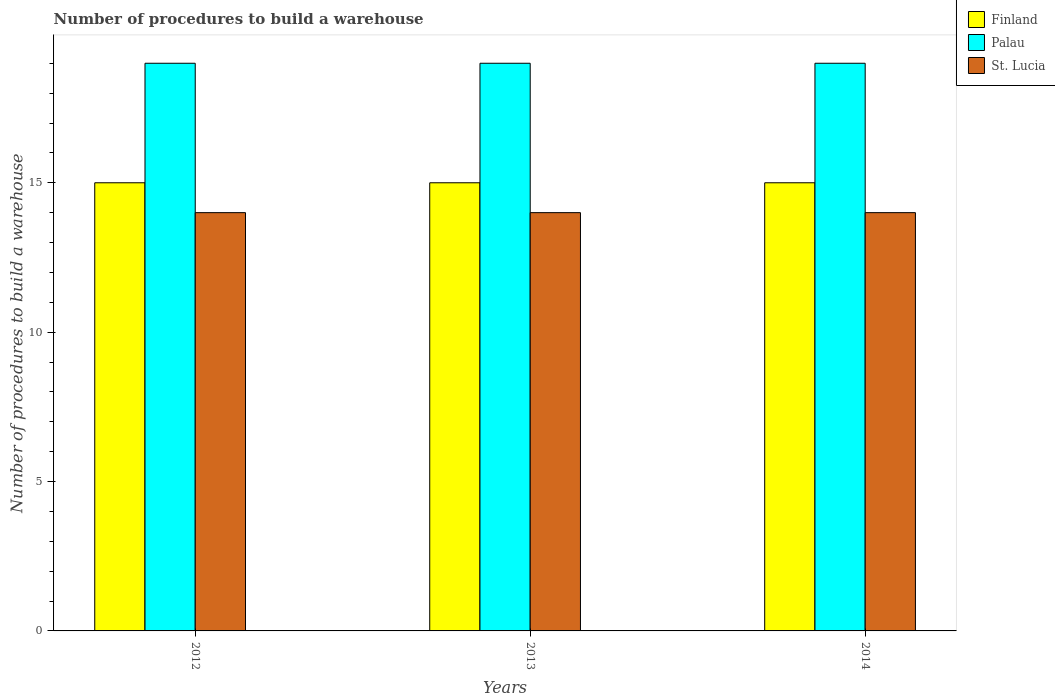How many bars are there on the 1st tick from the left?
Provide a short and direct response. 3. How many bars are there on the 2nd tick from the right?
Your answer should be very brief. 3. What is the label of the 1st group of bars from the left?
Give a very brief answer. 2012. In how many cases, is the number of bars for a given year not equal to the number of legend labels?
Keep it short and to the point. 0. What is the number of procedures to build a warehouse in in St. Lucia in 2013?
Offer a very short reply. 14. Across all years, what is the maximum number of procedures to build a warehouse in in St. Lucia?
Offer a terse response. 14. Across all years, what is the minimum number of procedures to build a warehouse in in Finland?
Ensure brevity in your answer.  15. In which year was the number of procedures to build a warehouse in in Finland maximum?
Your answer should be compact. 2012. In which year was the number of procedures to build a warehouse in in Palau minimum?
Provide a short and direct response. 2012. What is the total number of procedures to build a warehouse in in St. Lucia in the graph?
Provide a short and direct response. 42. What is the difference between the number of procedures to build a warehouse in in Finland in 2012 and that in 2013?
Provide a succinct answer. 0. What is the difference between the number of procedures to build a warehouse in in Finland in 2014 and the number of procedures to build a warehouse in in St. Lucia in 2013?
Provide a succinct answer. 1. In the year 2014, what is the difference between the number of procedures to build a warehouse in in Finland and number of procedures to build a warehouse in in St. Lucia?
Give a very brief answer. 1. In how many years, is the number of procedures to build a warehouse in in Finland greater than 5?
Your answer should be very brief. 3. Is the difference between the number of procedures to build a warehouse in in Finland in 2013 and 2014 greater than the difference between the number of procedures to build a warehouse in in St. Lucia in 2013 and 2014?
Ensure brevity in your answer.  No. What does the 1st bar from the left in 2013 represents?
Make the answer very short. Finland. What does the 1st bar from the right in 2012 represents?
Offer a terse response. St. Lucia. How many bars are there?
Your answer should be compact. 9. How many years are there in the graph?
Give a very brief answer. 3. What is the difference between two consecutive major ticks on the Y-axis?
Make the answer very short. 5. Are the values on the major ticks of Y-axis written in scientific E-notation?
Your answer should be very brief. No. How are the legend labels stacked?
Keep it short and to the point. Vertical. What is the title of the graph?
Your response must be concise. Number of procedures to build a warehouse. Does "West Bank and Gaza" appear as one of the legend labels in the graph?
Make the answer very short. No. What is the label or title of the Y-axis?
Offer a very short reply. Number of procedures to build a warehouse. What is the Number of procedures to build a warehouse in St. Lucia in 2012?
Provide a succinct answer. 14. What is the Number of procedures to build a warehouse of Finland in 2013?
Ensure brevity in your answer.  15. What is the Number of procedures to build a warehouse in Palau in 2013?
Your answer should be compact. 19. What is the Number of procedures to build a warehouse in St. Lucia in 2013?
Provide a succinct answer. 14. Across all years, what is the maximum Number of procedures to build a warehouse in Finland?
Ensure brevity in your answer.  15. Across all years, what is the maximum Number of procedures to build a warehouse of Palau?
Offer a terse response. 19. Across all years, what is the minimum Number of procedures to build a warehouse in Finland?
Offer a terse response. 15. Across all years, what is the minimum Number of procedures to build a warehouse in St. Lucia?
Provide a short and direct response. 14. What is the total Number of procedures to build a warehouse in St. Lucia in the graph?
Provide a succinct answer. 42. What is the difference between the Number of procedures to build a warehouse of Finland in 2012 and that in 2013?
Keep it short and to the point. 0. What is the difference between the Number of procedures to build a warehouse in Palau in 2012 and that in 2013?
Offer a very short reply. 0. What is the difference between the Number of procedures to build a warehouse of St. Lucia in 2012 and that in 2013?
Offer a terse response. 0. What is the difference between the Number of procedures to build a warehouse in Palau in 2012 and that in 2014?
Your answer should be very brief. 0. What is the difference between the Number of procedures to build a warehouse of Palau in 2013 and that in 2014?
Give a very brief answer. 0. What is the difference between the Number of procedures to build a warehouse of Palau in 2012 and the Number of procedures to build a warehouse of St. Lucia in 2013?
Your answer should be compact. 5. What is the difference between the Number of procedures to build a warehouse in Finland in 2012 and the Number of procedures to build a warehouse in Palau in 2014?
Offer a terse response. -4. What is the difference between the Number of procedures to build a warehouse in Palau in 2012 and the Number of procedures to build a warehouse in St. Lucia in 2014?
Keep it short and to the point. 5. What is the difference between the Number of procedures to build a warehouse in Finland in 2013 and the Number of procedures to build a warehouse in Palau in 2014?
Keep it short and to the point. -4. What is the average Number of procedures to build a warehouse of Finland per year?
Your answer should be very brief. 15. What is the average Number of procedures to build a warehouse in Palau per year?
Provide a succinct answer. 19. What is the average Number of procedures to build a warehouse of St. Lucia per year?
Keep it short and to the point. 14. In the year 2012, what is the difference between the Number of procedures to build a warehouse in Palau and Number of procedures to build a warehouse in St. Lucia?
Make the answer very short. 5. In the year 2013, what is the difference between the Number of procedures to build a warehouse of Finland and Number of procedures to build a warehouse of Palau?
Give a very brief answer. -4. In the year 2013, what is the difference between the Number of procedures to build a warehouse in Finland and Number of procedures to build a warehouse in St. Lucia?
Provide a short and direct response. 1. In the year 2013, what is the difference between the Number of procedures to build a warehouse in Palau and Number of procedures to build a warehouse in St. Lucia?
Your answer should be very brief. 5. In the year 2014, what is the difference between the Number of procedures to build a warehouse in Finland and Number of procedures to build a warehouse in Palau?
Offer a very short reply. -4. What is the ratio of the Number of procedures to build a warehouse of St. Lucia in 2012 to that in 2013?
Offer a terse response. 1. What is the ratio of the Number of procedures to build a warehouse of Finland in 2012 to that in 2014?
Provide a short and direct response. 1. What is the ratio of the Number of procedures to build a warehouse of Palau in 2012 to that in 2014?
Your response must be concise. 1. What is the ratio of the Number of procedures to build a warehouse in Palau in 2013 to that in 2014?
Your answer should be compact. 1. What is the ratio of the Number of procedures to build a warehouse in St. Lucia in 2013 to that in 2014?
Offer a terse response. 1. What is the difference between the highest and the second highest Number of procedures to build a warehouse of Finland?
Your answer should be very brief. 0. What is the difference between the highest and the second highest Number of procedures to build a warehouse in St. Lucia?
Ensure brevity in your answer.  0. What is the difference between the highest and the lowest Number of procedures to build a warehouse in Finland?
Offer a very short reply. 0. What is the difference between the highest and the lowest Number of procedures to build a warehouse in Palau?
Your response must be concise. 0. What is the difference between the highest and the lowest Number of procedures to build a warehouse in St. Lucia?
Ensure brevity in your answer.  0. 